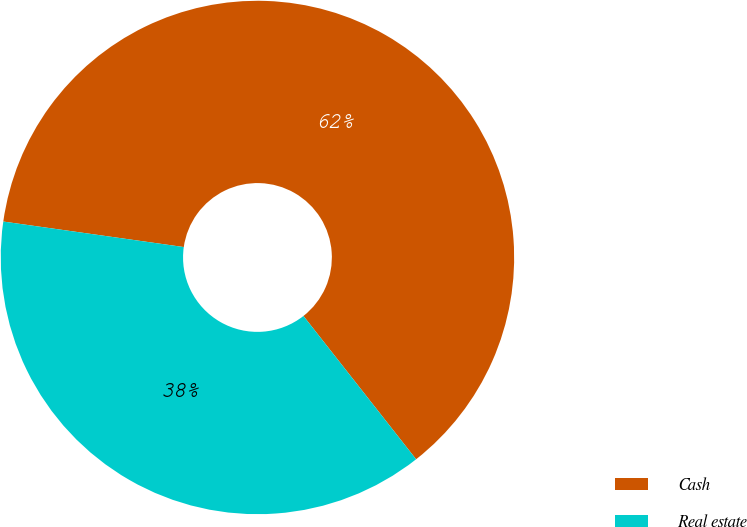Convert chart to OTSL. <chart><loc_0><loc_0><loc_500><loc_500><pie_chart><fcel>Cash<fcel>Real estate<nl><fcel>62.16%<fcel>37.84%<nl></chart> 